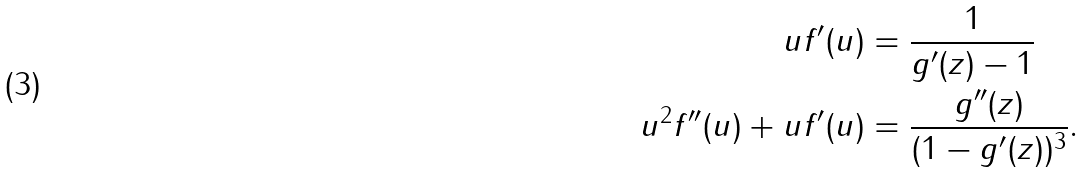Convert formula to latex. <formula><loc_0><loc_0><loc_500><loc_500>u f ^ { \prime } ( u ) & = \frac { 1 } { g ^ { \prime } ( z ) - 1 } \\ u ^ { 2 } f ^ { \prime \prime } ( u ) + u f ^ { \prime } ( u ) & = \frac { g ^ { \prime \prime } ( z ) } { ( 1 - g ^ { \prime } ( z ) ) ^ { 3 } } .</formula> 